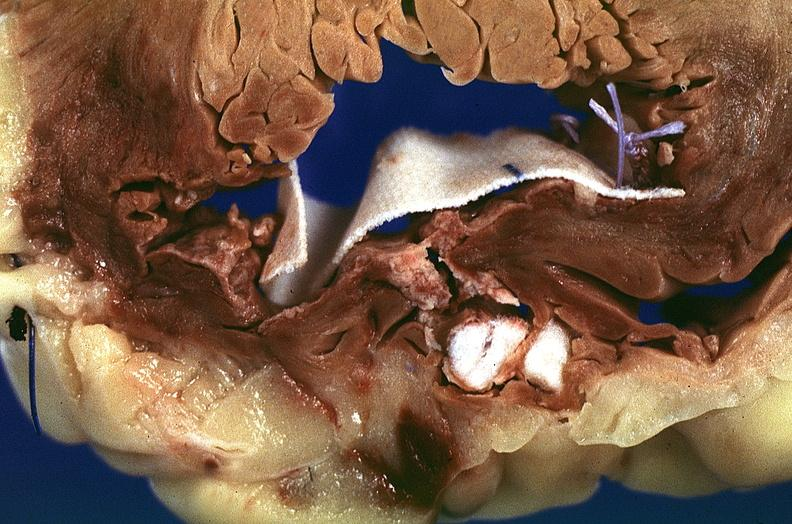where is this?
Answer the question using a single word or phrase. Heart 